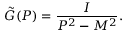<formula> <loc_0><loc_0><loc_500><loc_500>\tilde { G } ( P ) = \frac { I } { P ^ { 2 } - M ^ { 2 } } .</formula> 